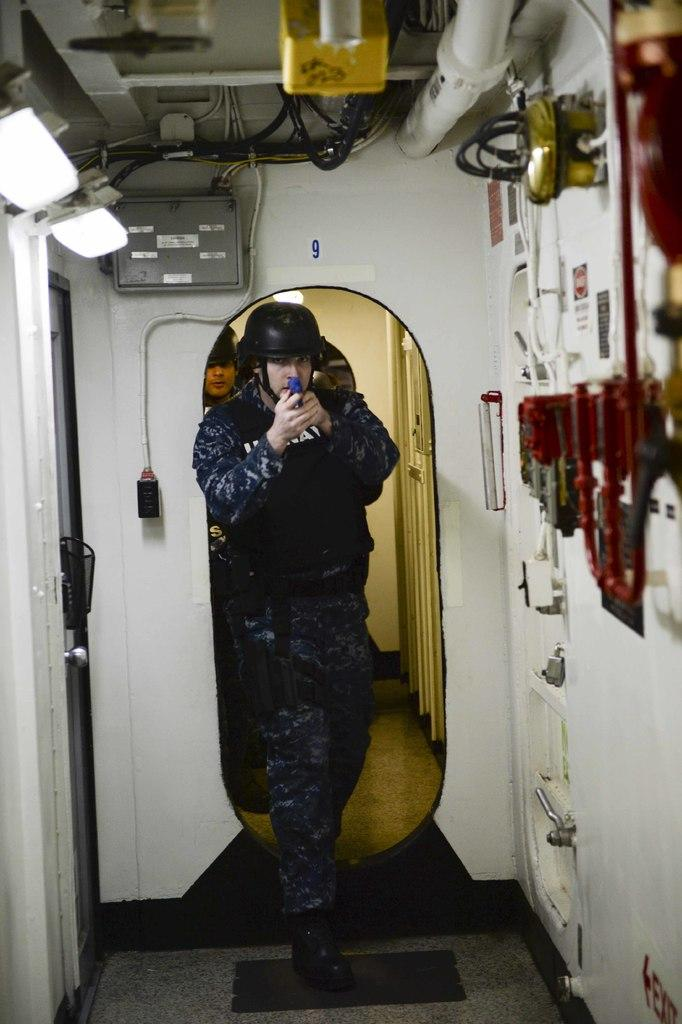What is the man in the image holding? The man is holding an object. What type of protective gear is the man wearing? The man is wearing a helmet. What can be seen on the left side of the image? There are lights, cables, and an electrical device on the left side of the image. Can you describe the background of the image? There is a person's face visible in the background of the image, and there is light visible as well. How does the man increase the speed of the object he is holding in the image? The image does not provide information about the object's speed or how to increase it. --- Facts: 1. There is a car in the image. 2. The car is parked on the street. 3. There are trees on the right side of the image. 4. There is a sidewalk on the left side of the image. 5. There are streetlights visible in the image. 6. The car has a red color. Absurd Topics: dance, swim, paint Conversation: What type of vehicle is in the image? There is a car in the image. Where is the car located in the image? The car is parked on the street. What can be seen on the right side of the image? There are trees on the right side of the image. What is on the left side of the image? There is a sidewalk on the left side of the image. What type of lighting is present in the image? There are streetlights visible in the image. What color is the car in the image? The car has a red color. Reasoning: Let's think step by step in order to produce the conversation. We start by identifying the main subject in the image, which is the car. Then, we expand the conversation to include details about the car's location, the surrounding environment, and the presence of streetlights. We also mention the car's color to provide a more complete description. Absurd Question/Answer: Can you tell me how many people are dancing on the car in the image? There is no dancing or people on the car in the image; it is parked on the street. 